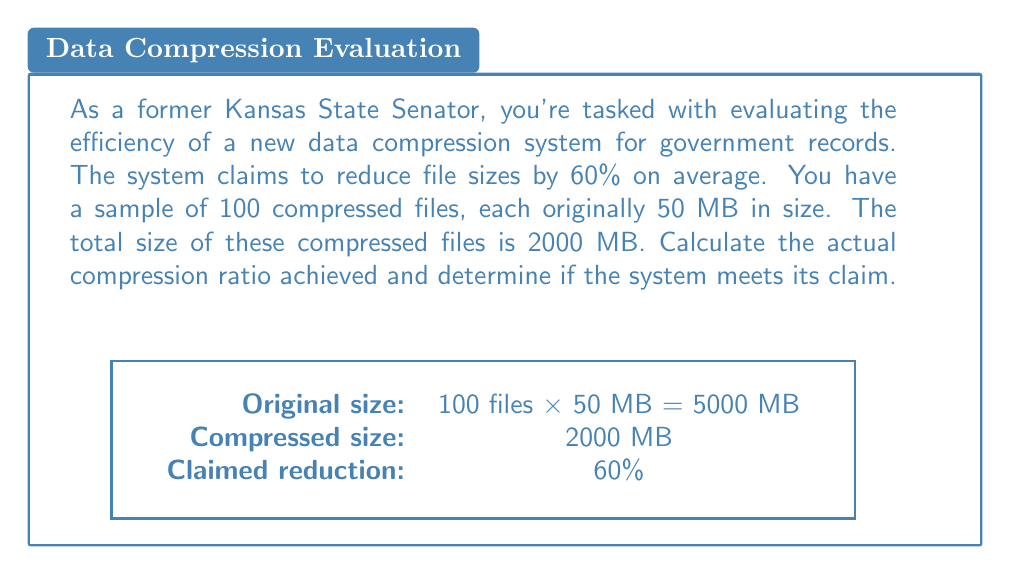Give your solution to this math problem. Let's approach this step-by-step:

1) First, we need to calculate the total original size of the files:
   Original size = 100 files × 50 MB = 5000 MB

2) We're given that the total compressed size is 2000 MB.

3) To calculate the compression ratio, we use the formula:
   $$ \text{Compression Ratio} = 1 - \frac{\text{Compressed Size}}{\text{Original Size}} $$

4) Plugging in our values:
   $$ \text{Compression Ratio} = 1 - \frac{2000 \text{ MB}}{5000 \text{ MB}} = 1 - 0.4 = 0.6 $$

5) To express this as a percentage:
   Compression Ratio = 0.6 × 100% = 60%

6) The system claimed to reduce file sizes by 60% on average, which is equivalent to a compression ratio of 60%.

7) Our calculated compression ratio matches the claim exactly.

Therefore, based on this sample, the system does meet its claim of 60% compression.
Answer: 60%; claim met 